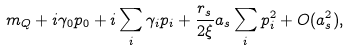Convert formula to latex. <formula><loc_0><loc_0><loc_500><loc_500>m _ { Q } + i \gamma _ { 0 } p _ { 0 } + i \sum _ { i } \gamma _ { i } p _ { i } + \frac { r _ { s } } { 2 \xi } a _ { s } \sum _ { i } p _ { i } ^ { 2 } + O ( a _ { s } ^ { 2 } ) ,</formula> 